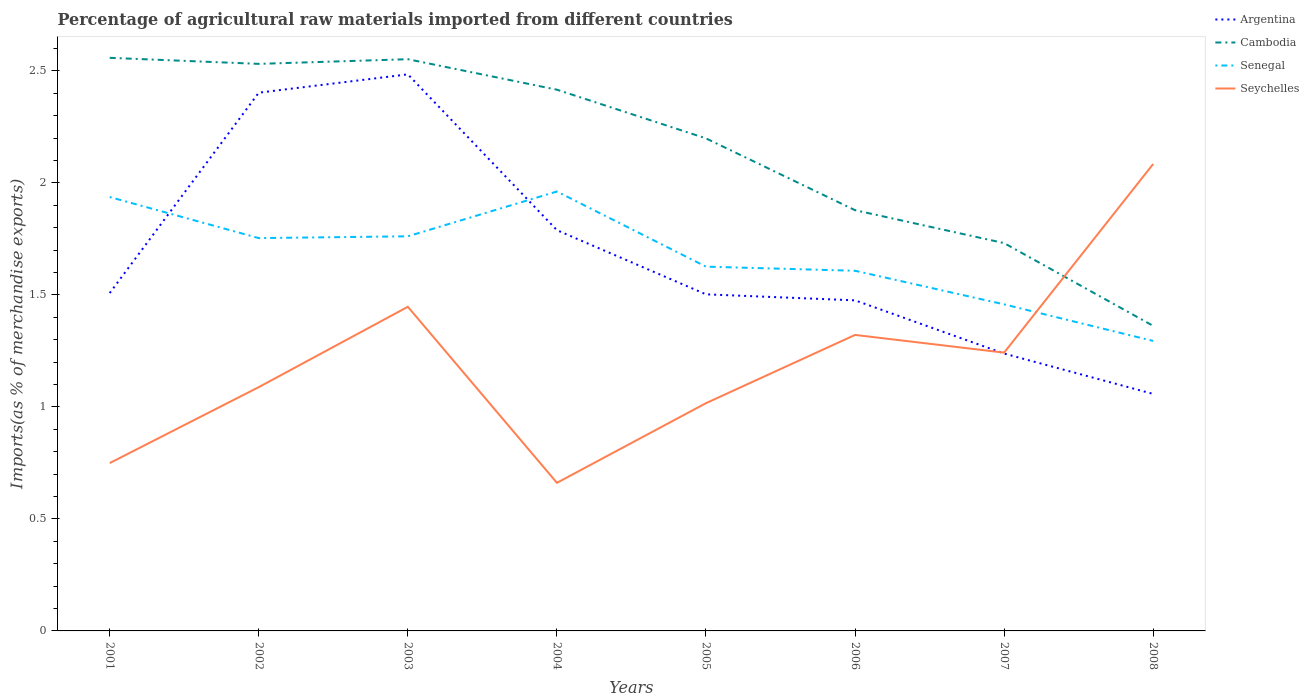How many different coloured lines are there?
Give a very brief answer. 4. Does the line corresponding to Senegal intersect with the line corresponding to Argentina?
Give a very brief answer. Yes. Across all years, what is the maximum percentage of imports to different countries in Seychelles?
Your response must be concise. 0.66. In which year was the percentage of imports to different countries in Cambodia maximum?
Give a very brief answer. 2008. What is the total percentage of imports to different countries in Senegal in the graph?
Offer a terse response. 0.64. What is the difference between the highest and the second highest percentage of imports to different countries in Senegal?
Your answer should be compact. 0.67. What is the difference between the highest and the lowest percentage of imports to different countries in Cambodia?
Provide a succinct answer. 5. How many lines are there?
Keep it short and to the point. 4. How many years are there in the graph?
Your answer should be very brief. 8. Are the values on the major ticks of Y-axis written in scientific E-notation?
Ensure brevity in your answer.  No. Does the graph contain grids?
Make the answer very short. No. What is the title of the graph?
Give a very brief answer. Percentage of agricultural raw materials imported from different countries. Does "St. Lucia" appear as one of the legend labels in the graph?
Give a very brief answer. No. What is the label or title of the Y-axis?
Your answer should be compact. Imports(as % of merchandise exports). What is the Imports(as % of merchandise exports) in Argentina in 2001?
Make the answer very short. 1.51. What is the Imports(as % of merchandise exports) in Cambodia in 2001?
Your answer should be very brief. 2.56. What is the Imports(as % of merchandise exports) in Senegal in 2001?
Provide a succinct answer. 1.94. What is the Imports(as % of merchandise exports) of Seychelles in 2001?
Make the answer very short. 0.75. What is the Imports(as % of merchandise exports) of Argentina in 2002?
Ensure brevity in your answer.  2.4. What is the Imports(as % of merchandise exports) of Cambodia in 2002?
Offer a terse response. 2.53. What is the Imports(as % of merchandise exports) of Senegal in 2002?
Provide a short and direct response. 1.75. What is the Imports(as % of merchandise exports) of Seychelles in 2002?
Provide a short and direct response. 1.09. What is the Imports(as % of merchandise exports) in Argentina in 2003?
Offer a terse response. 2.48. What is the Imports(as % of merchandise exports) of Cambodia in 2003?
Your answer should be very brief. 2.55. What is the Imports(as % of merchandise exports) of Senegal in 2003?
Your answer should be compact. 1.76. What is the Imports(as % of merchandise exports) of Seychelles in 2003?
Ensure brevity in your answer.  1.45. What is the Imports(as % of merchandise exports) in Argentina in 2004?
Offer a terse response. 1.79. What is the Imports(as % of merchandise exports) of Cambodia in 2004?
Ensure brevity in your answer.  2.42. What is the Imports(as % of merchandise exports) of Senegal in 2004?
Provide a short and direct response. 1.96. What is the Imports(as % of merchandise exports) in Seychelles in 2004?
Your answer should be compact. 0.66. What is the Imports(as % of merchandise exports) in Argentina in 2005?
Provide a short and direct response. 1.5. What is the Imports(as % of merchandise exports) of Cambodia in 2005?
Keep it short and to the point. 2.2. What is the Imports(as % of merchandise exports) in Senegal in 2005?
Provide a succinct answer. 1.63. What is the Imports(as % of merchandise exports) in Seychelles in 2005?
Ensure brevity in your answer.  1.02. What is the Imports(as % of merchandise exports) in Argentina in 2006?
Offer a terse response. 1.48. What is the Imports(as % of merchandise exports) of Cambodia in 2006?
Give a very brief answer. 1.88. What is the Imports(as % of merchandise exports) in Senegal in 2006?
Provide a succinct answer. 1.61. What is the Imports(as % of merchandise exports) in Seychelles in 2006?
Provide a short and direct response. 1.32. What is the Imports(as % of merchandise exports) of Argentina in 2007?
Offer a terse response. 1.24. What is the Imports(as % of merchandise exports) of Cambodia in 2007?
Give a very brief answer. 1.73. What is the Imports(as % of merchandise exports) of Senegal in 2007?
Offer a terse response. 1.46. What is the Imports(as % of merchandise exports) in Seychelles in 2007?
Offer a terse response. 1.24. What is the Imports(as % of merchandise exports) of Argentina in 2008?
Ensure brevity in your answer.  1.06. What is the Imports(as % of merchandise exports) in Cambodia in 2008?
Your response must be concise. 1.36. What is the Imports(as % of merchandise exports) of Senegal in 2008?
Ensure brevity in your answer.  1.29. What is the Imports(as % of merchandise exports) in Seychelles in 2008?
Give a very brief answer. 2.08. Across all years, what is the maximum Imports(as % of merchandise exports) in Argentina?
Ensure brevity in your answer.  2.48. Across all years, what is the maximum Imports(as % of merchandise exports) of Cambodia?
Your response must be concise. 2.56. Across all years, what is the maximum Imports(as % of merchandise exports) of Senegal?
Give a very brief answer. 1.96. Across all years, what is the maximum Imports(as % of merchandise exports) in Seychelles?
Provide a succinct answer. 2.08. Across all years, what is the minimum Imports(as % of merchandise exports) of Argentina?
Provide a succinct answer. 1.06. Across all years, what is the minimum Imports(as % of merchandise exports) in Cambodia?
Give a very brief answer. 1.36. Across all years, what is the minimum Imports(as % of merchandise exports) in Senegal?
Your answer should be compact. 1.29. Across all years, what is the minimum Imports(as % of merchandise exports) in Seychelles?
Offer a very short reply. 0.66. What is the total Imports(as % of merchandise exports) of Argentina in the graph?
Give a very brief answer. 13.46. What is the total Imports(as % of merchandise exports) of Cambodia in the graph?
Keep it short and to the point. 17.23. What is the total Imports(as % of merchandise exports) of Senegal in the graph?
Keep it short and to the point. 13.4. What is the total Imports(as % of merchandise exports) in Seychelles in the graph?
Keep it short and to the point. 9.61. What is the difference between the Imports(as % of merchandise exports) in Argentina in 2001 and that in 2002?
Your response must be concise. -0.89. What is the difference between the Imports(as % of merchandise exports) in Cambodia in 2001 and that in 2002?
Your response must be concise. 0.03. What is the difference between the Imports(as % of merchandise exports) in Senegal in 2001 and that in 2002?
Offer a very short reply. 0.18. What is the difference between the Imports(as % of merchandise exports) in Seychelles in 2001 and that in 2002?
Your response must be concise. -0.34. What is the difference between the Imports(as % of merchandise exports) of Argentina in 2001 and that in 2003?
Give a very brief answer. -0.98. What is the difference between the Imports(as % of merchandise exports) in Cambodia in 2001 and that in 2003?
Your response must be concise. 0.01. What is the difference between the Imports(as % of merchandise exports) of Senegal in 2001 and that in 2003?
Your response must be concise. 0.18. What is the difference between the Imports(as % of merchandise exports) of Seychelles in 2001 and that in 2003?
Provide a short and direct response. -0.7. What is the difference between the Imports(as % of merchandise exports) in Argentina in 2001 and that in 2004?
Your response must be concise. -0.28. What is the difference between the Imports(as % of merchandise exports) of Cambodia in 2001 and that in 2004?
Offer a very short reply. 0.14. What is the difference between the Imports(as % of merchandise exports) in Senegal in 2001 and that in 2004?
Your response must be concise. -0.02. What is the difference between the Imports(as % of merchandise exports) of Seychelles in 2001 and that in 2004?
Your answer should be very brief. 0.09. What is the difference between the Imports(as % of merchandise exports) in Argentina in 2001 and that in 2005?
Provide a short and direct response. 0.01. What is the difference between the Imports(as % of merchandise exports) of Cambodia in 2001 and that in 2005?
Give a very brief answer. 0.36. What is the difference between the Imports(as % of merchandise exports) of Senegal in 2001 and that in 2005?
Offer a terse response. 0.31. What is the difference between the Imports(as % of merchandise exports) of Seychelles in 2001 and that in 2005?
Make the answer very short. -0.27. What is the difference between the Imports(as % of merchandise exports) in Argentina in 2001 and that in 2006?
Provide a short and direct response. 0.03. What is the difference between the Imports(as % of merchandise exports) in Cambodia in 2001 and that in 2006?
Offer a terse response. 0.68. What is the difference between the Imports(as % of merchandise exports) in Senegal in 2001 and that in 2006?
Your answer should be very brief. 0.33. What is the difference between the Imports(as % of merchandise exports) in Seychelles in 2001 and that in 2006?
Keep it short and to the point. -0.57. What is the difference between the Imports(as % of merchandise exports) in Argentina in 2001 and that in 2007?
Give a very brief answer. 0.27. What is the difference between the Imports(as % of merchandise exports) of Cambodia in 2001 and that in 2007?
Provide a short and direct response. 0.83. What is the difference between the Imports(as % of merchandise exports) in Senegal in 2001 and that in 2007?
Give a very brief answer. 0.48. What is the difference between the Imports(as % of merchandise exports) in Seychelles in 2001 and that in 2007?
Your response must be concise. -0.49. What is the difference between the Imports(as % of merchandise exports) of Argentina in 2001 and that in 2008?
Ensure brevity in your answer.  0.45. What is the difference between the Imports(as % of merchandise exports) in Cambodia in 2001 and that in 2008?
Offer a terse response. 1.2. What is the difference between the Imports(as % of merchandise exports) in Senegal in 2001 and that in 2008?
Your answer should be compact. 0.64. What is the difference between the Imports(as % of merchandise exports) in Seychelles in 2001 and that in 2008?
Keep it short and to the point. -1.34. What is the difference between the Imports(as % of merchandise exports) of Argentina in 2002 and that in 2003?
Give a very brief answer. -0.08. What is the difference between the Imports(as % of merchandise exports) in Cambodia in 2002 and that in 2003?
Keep it short and to the point. -0.02. What is the difference between the Imports(as % of merchandise exports) in Senegal in 2002 and that in 2003?
Provide a succinct answer. -0.01. What is the difference between the Imports(as % of merchandise exports) of Seychelles in 2002 and that in 2003?
Make the answer very short. -0.36. What is the difference between the Imports(as % of merchandise exports) in Argentina in 2002 and that in 2004?
Your response must be concise. 0.61. What is the difference between the Imports(as % of merchandise exports) in Cambodia in 2002 and that in 2004?
Keep it short and to the point. 0.12. What is the difference between the Imports(as % of merchandise exports) in Senegal in 2002 and that in 2004?
Offer a terse response. -0.21. What is the difference between the Imports(as % of merchandise exports) in Seychelles in 2002 and that in 2004?
Make the answer very short. 0.43. What is the difference between the Imports(as % of merchandise exports) in Argentina in 2002 and that in 2005?
Provide a succinct answer. 0.9. What is the difference between the Imports(as % of merchandise exports) of Cambodia in 2002 and that in 2005?
Provide a short and direct response. 0.33. What is the difference between the Imports(as % of merchandise exports) in Senegal in 2002 and that in 2005?
Keep it short and to the point. 0.13. What is the difference between the Imports(as % of merchandise exports) in Seychelles in 2002 and that in 2005?
Ensure brevity in your answer.  0.07. What is the difference between the Imports(as % of merchandise exports) in Argentina in 2002 and that in 2006?
Give a very brief answer. 0.93. What is the difference between the Imports(as % of merchandise exports) in Cambodia in 2002 and that in 2006?
Provide a short and direct response. 0.65. What is the difference between the Imports(as % of merchandise exports) of Senegal in 2002 and that in 2006?
Give a very brief answer. 0.15. What is the difference between the Imports(as % of merchandise exports) in Seychelles in 2002 and that in 2006?
Provide a short and direct response. -0.23. What is the difference between the Imports(as % of merchandise exports) of Argentina in 2002 and that in 2007?
Provide a succinct answer. 1.16. What is the difference between the Imports(as % of merchandise exports) of Cambodia in 2002 and that in 2007?
Provide a succinct answer. 0.8. What is the difference between the Imports(as % of merchandise exports) of Senegal in 2002 and that in 2007?
Your response must be concise. 0.3. What is the difference between the Imports(as % of merchandise exports) of Seychelles in 2002 and that in 2007?
Provide a short and direct response. -0.15. What is the difference between the Imports(as % of merchandise exports) of Argentina in 2002 and that in 2008?
Provide a succinct answer. 1.34. What is the difference between the Imports(as % of merchandise exports) in Cambodia in 2002 and that in 2008?
Provide a short and direct response. 1.17. What is the difference between the Imports(as % of merchandise exports) of Senegal in 2002 and that in 2008?
Ensure brevity in your answer.  0.46. What is the difference between the Imports(as % of merchandise exports) of Seychelles in 2002 and that in 2008?
Your answer should be compact. -1. What is the difference between the Imports(as % of merchandise exports) of Argentina in 2003 and that in 2004?
Offer a terse response. 0.7. What is the difference between the Imports(as % of merchandise exports) in Cambodia in 2003 and that in 2004?
Offer a terse response. 0.14. What is the difference between the Imports(as % of merchandise exports) of Seychelles in 2003 and that in 2004?
Your answer should be compact. 0.79. What is the difference between the Imports(as % of merchandise exports) of Argentina in 2003 and that in 2005?
Your answer should be compact. 0.98. What is the difference between the Imports(as % of merchandise exports) in Cambodia in 2003 and that in 2005?
Your answer should be very brief. 0.35. What is the difference between the Imports(as % of merchandise exports) in Senegal in 2003 and that in 2005?
Your response must be concise. 0.14. What is the difference between the Imports(as % of merchandise exports) in Seychelles in 2003 and that in 2005?
Give a very brief answer. 0.43. What is the difference between the Imports(as % of merchandise exports) of Argentina in 2003 and that in 2006?
Provide a short and direct response. 1.01. What is the difference between the Imports(as % of merchandise exports) in Cambodia in 2003 and that in 2006?
Your response must be concise. 0.67. What is the difference between the Imports(as % of merchandise exports) of Senegal in 2003 and that in 2006?
Give a very brief answer. 0.15. What is the difference between the Imports(as % of merchandise exports) in Seychelles in 2003 and that in 2006?
Keep it short and to the point. 0.13. What is the difference between the Imports(as % of merchandise exports) in Argentina in 2003 and that in 2007?
Make the answer very short. 1.25. What is the difference between the Imports(as % of merchandise exports) in Cambodia in 2003 and that in 2007?
Your answer should be compact. 0.82. What is the difference between the Imports(as % of merchandise exports) in Senegal in 2003 and that in 2007?
Provide a succinct answer. 0.3. What is the difference between the Imports(as % of merchandise exports) in Seychelles in 2003 and that in 2007?
Ensure brevity in your answer.  0.2. What is the difference between the Imports(as % of merchandise exports) of Argentina in 2003 and that in 2008?
Your answer should be very brief. 1.43. What is the difference between the Imports(as % of merchandise exports) of Cambodia in 2003 and that in 2008?
Offer a very short reply. 1.19. What is the difference between the Imports(as % of merchandise exports) in Senegal in 2003 and that in 2008?
Offer a terse response. 0.47. What is the difference between the Imports(as % of merchandise exports) in Seychelles in 2003 and that in 2008?
Provide a succinct answer. -0.64. What is the difference between the Imports(as % of merchandise exports) of Argentina in 2004 and that in 2005?
Offer a very short reply. 0.29. What is the difference between the Imports(as % of merchandise exports) of Cambodia in 2004 and that in 2005?
Offer a very short reply. 0.22. What is the difference between the Imports(as % of merchandise exports) in Senegal in 2004 and that in 2005?
Provide a succinct answer. 0.34. What is the difference between the Imports(as % of merchandise exports) of Seychelles in 2004 and that in 2005?
Your answer should be very brief. -0.36. What is the difference between the Imports(as % of merchandise exports) in Argentina in 2004 and that in 2006?
Your response must be concise. 0.31. What is the difference between the Imports(as % of merchandise exports) of Cambodia in 2004 and that in 2006?
Provide a short and direct response. 0.54. What is the difference between the Imports(as % of merchandise exports) of Senegal in 2004 and that in 2006?
Give a very brief answer. 0.35. What is the difference between the Imports(as % of merchandise exports) of Seychelles in 2004 and that in 2006?
Offer a very short reply. -0.66. What is the difference between the Imports(as % of merchandise exports) of Argentina in 2004 and that in 2007?
Give a very brief answer. 0.55. What is the difference between the Imports(as % of merchandise exports) of Cambodia in 2004 and that in 2007?
Keep it short and to the point. 0.68. What is the difference between the Imports(as % of merchandise exports) in Senegal in 2004 and that in 2007?
Offer a terse response. 0.5. What is the difference between the Imports(as % of merchandise exports) in Seychelles in 2004 and that in 2007?
Keep it short and to the point. -0.58. What is the difference between the Imports(as % of merchandise exports) of Argentina in 2004 and that in 2008?
Provide a succinct answer. 0.73. What is the difference between the Imports(as % of merchandise exports) in Cambodia in 2004 and that in 2008?
Your answer should be compact. 1.05. What is the difference between the Imports(as % of merchandise exports) in Senegal in 2004 and that in 2008?
Give a very brief answer. 0.67. What is the difference between the Imports(as % of merchandise exports) in Seychelles in 2004 and that in 2008?
Offer a terse response. -1.42. What is the difference between the Imports(as % of merchandise exports) of Argentina in 2005 and that in 2006?
Your answer should be very brief. 0.03. What is the difference between the Imports(as % of merchandise exports) in Cambodia in 2005 and that in 2006?
Make the answer very short. 0.32. What is the difference between the Imports(as % of merchandise exports) of Senegal in 2005 and that in 2006?
Keep it short and to the point. 0.02. What is the difference between the Imports(as % of merchandise exports) of Seychelles in 2005 and that in 2006?
Your response must be concise. -0.3. What is the difference between the Imports(as % of merchandise exports) of Argentina in 2005 and that in 2007?
Offer a very short reply. 0.26. What is the difference between the Imports(as % of merchandise exports) of Cambodia in 2005 and that in 2007?
Offer a very short reply. 0.47. What is the difference between the Imports(as % of merchandise exports) in Senegal in 2005 and that in 2007?
Your answer should be compact. 0.17. What is the difference between the Imports(as % of merchandise exports) of Seychelles in 2005 and that in 2007?
Give a very brief answer. -0.23. What is the difference between the Imports(as % of merchandise exports) of Argentina in 2005 and that in 2008?
Offer a very short reply. 0.44. What is the difference between the Imports(as % of merchandise exports) in Cambodia in 2005 and that in 2008?
Keep it short and to the point. 0.84. What is the difference between the Imports(as % of merchandise exports) of Senegal in 2005 and that in 2008?
Ensure brevity in your answer.  0.33. What is the difference between the Imports(as % of merchandise exports) of Seychelles in 2005 and that in 2008?
Give a very brief answer. -1.07. What is the difference between the Imports(as % of merchandise exports) of Argentina in 2006 and that in 2007?
Provide a succinct answer. 0.24. What is the difference between the Imports(as % of merchandise exports) in Cambodia in 2006 and that in 2007?
Provide a short and direct response. 0.15. What is the difference between the Imports(as % of merchandise exports) in Seychelles in 2006 and that in 2007?
Provide a succinct answer. 0.08. What is the difference between the Imports(as % of merchandise exports) in Argentina in 2006 and that in 2008?
Provide a short and direct response. 0.42. What is the difference between the Imports(as % of merchandise exports) in Cambodia in 2006 and that in 2008?
Provide a succinct answer. 0.52. What is the difference between the Imports(as % of merchandise exports) in Senegal in 2006 and that in 2008?
Provide a succinct answer. 0.31. What is the difference between the Imports(as % of merchandise exports) of Seychelles in 2006 and that in 2008?
Your answer should be compact. -0.76. What is the difference between the Imports(as % of merchandise exports) in Argentina in 2007 and that in 2008?
Give a very brief answer. 0.18. What is the difference between the Imports(as % of merchandise exports) in Cambodia in 2007 and that in 2008?
Your answer should be very brief. 0.37. What is the difference between the Imports(as % of merchandise exports) of Senegal in 2007 and that in 2008?
Give a very brief answer. 0.16. What is the difference between the Imports(as % of merchandise exports) in Seychelles in 2007 and that in 2008?
Offer a very short reply. -0.84. What is the difference between the Imports(as % of merchandise exports) of Argentina in 2001 and the Imports(as % of merchandise exports) of Cambodia in 2002?
Offer a very short reply. -1.02. What is the difference between the Imports(as % of merchandise exports) of Argentina in 2001 and the Imports(as % of merchandise exports) of Senegal in 2002?
Your answer should be very brief. -0.25. What is the difference between the Imports(as % of merchandise exports) in Argentina in 2001 and the Imports(as % of merchandise exports) in Seychelles in 2002?
Your response must be concise. 0.42. What is the difference between the Imports(as % of merchandise exports) in Cambodia in 2001 and the Imports(as % of merchandise exports) in Senegal in 2002?
Offer a terse response. 0.8. What is the difference between the Imports(as % of merchandise exports) of Cambodia in 2001 and the Imports(as % of merchandise exports) of Seychelles in 2002?
Provide a short and direct response. 1.47. What is the difference between the Imports(as % of merchandise exports) in Senegal in 2001 and the Imports(as % of merchandise exports) in Seychelles in 2002?
Your answer should be compact. 0.85. What is the difference between the Imports(as % of merchandise exports) of Argentina in 2001 and the Imports(as % of merchandise exports) of Cambodia in 2003?
Offer a terse response. -1.04. What is the difference between the Imports(as % of merchandise exports) in Argentina in 2001 and the Imports(as % of merchandise exports) in Senegal in 2003?
Offer a terse response. -0.25. What is the difference between the Imports(as % of merchandise exports) in Argentina in 2001 and the Imports(as % of merchandise exports) in Seychelles in 2003?
Offer a very short reply. 0.06. What is the difference between the Imports(as % of merchandise exports) of Cambodia in 2001 and the Imports(as % of merchandise exports) of Senegal in 2003?
Offer a terse response. 0.8. What is the difference between the Imports(as % of merchandise exports) in Cambodia in 2001 and the Imports(as % of merchandise exports) in Seychelles in 2003?
Ensure brevity in your answer.  1.11. What is the difference between the Imports(as % of merchandise exports) of Senegal in 2001 and the Imports(as % of merchandise exports) of Seychelles in 2003?
Your answer should be very brief. 0.49. What is the difference between the Imports(as % of merchandise exports) of Argentina in 2001 and the Imports(as % of merchandise exports) of Cambodia in 2004?
Ensure brevity in your answer.  -0.91. What is the difference between the Imports(as % of merchandise exports) in Argentina in 2001 and the Imports(as % of merchandise exports) in Senegal in 2004?
Offer a very short reply. -0.45. What is the difference between the Imports(as % of merchandise exports) of Argentina in 2001 and the Imports(as % of merchandise exports) of Seychelles in 2004?
Provide a succinct answer. 0.85. What is the difference between the Imports(as % of merchandise exports) in Cambodia in 2001 and the Imports(as % of merchandise exports) in Senegal in 2004?
Provide a succinct answer. 0.6. What is the difference between the Imports(as % of merchandise exports) of Cambodia in 2001 and the Imports(as % of merchandise exports) of Seychelles in 2004?
Your answer should be compact. 1.9. What is the difference between the Imports(as % of merchandise exports) in Senegal in 2001 and the Imports(as % of merchandise exports) in Seychelles in 2004?
Keep it short and to the point. 1.28. What is the difference between the Imports(as % of merchandise exports) of Argentina in 2001 and the Imports(as % of merchandise exports) of Cambodia in 2005?
Give a very brief answer. -0.69. What is the difference between the Imports(as % of merchandise exports) of Argentina in 2001 and the Imports(as % of merchandise exports) of Senegal in 2005?
Keep it short and to the point. -0.12. What is the difference between the Imports(as % of merchandise exports) of Argentina in 2001 and the Imports(as % of merchandise exports) of Seychelles in 2005?
Make the answer very short. 0.49. What is the difference between the Imports(as % of merchandise exports) of Cambodia in 2001 and the Imports(as % of merchandise exports) of Senegal in 2005?
Keep it short and to the point. 0.93. What is the difference between the Imports(as % of merchandise exports) in Cambodia in 2001 and the Imports(as % of merchandise exports) in Seychelles in 2005?
Make the answer very short. 1.54. What is the difference between the Imports(as % of merchandise exports) in Senegal in 2001 and the Imports(as % of merchandise exports) in Seychelles in 2005?
Your answer should be compact. 0.92. What is the difference between the Imports(as % of merchandise exports) in Argentina in 2001 and the Imports(as % of merchandise exports) in Cambodia in 2006?
Your answer should be very brief. -0.37. What is the difference between the Imports(as % of merchandise exports) in Argentina in 2001 and the Imports(as % of merchandise exports) in Senegal in 2006?
Offer a terse response. -0.1. What is the difference between the Imports(as % of merchandise exports) of Argentina in 2001 and the Imports(as % of merchandise exports) of Seychelles in 2006?
Offer a very short reply. 0.19. What is the difference between the Imports(as % of merchandise exports) of Cambodia in 2001 and the Imports(as % of merchandise exports) of Senegal in 2006?
Make the answer very short. 0.95. What is the difference between the Imports(as % of merchandise exports) in Cambodia in 2001 and the Imports(as % of merchandise exports) in Seychelles in 2006?
Your response must be concise. 1.24. What is the difference between the Imports(as % of merchandise exports) in Senegal in 2001 and the Imports(as % of merchandise exports) in Seychelles in 2006?
Your answer should be compact. 0.62. What is the difference between the Imports(as % of merchandise exports) in Argentina in 2001 and the Imports(as % of merchandise exports) in Cambodia in 2007?
Your response must be concise. -0.22. What is the difference between the Imports(as % of merchandise exports) of Argentina in 2001 and the Imports(as % of merchandise exports) of Senegal in 2007?
Offer a terse response. 0.05. What is the difference between the Imports(as % of merchandise exports) of Argentina in 2001 and the Imports(as % of merchandise exports) of Seychelles in 2007?
Keep it short and to the point. 0.27. What is the difference between the Imports(as % of merchandise exports) in Cambodia in 2001 and the Imports(as % of merchandise exports) in Senegal in 2007?
Make the answer very short. 1.1. What is the difference between the Imports(as % of merchandise exports) of Cambodia in 2001 and the Imports(as % of merchandise exports) of Seychelles in 2007?
Provide a succinct answer. 1.32. What is the difference between the Imports(as % of merchandise exports) in Senegal in 2001 and the Imports(as % of merchandise exports) in Seychelles in 2007?
Your answer should be compact. 0.69. What is the difference between the Imports(as % of merchandise exports) of Argentina in 2001 and the Imports(as % of merchandise exports) of Cambodia in 2008?
Provide a succinct answer. 0.15. What is the difference between the Imports(as % of merchandise exports) of Argentina in 2001 and the Imports(as % of merchandise exports) of Senegal in 2008?
Your answer should be compact. 0.21. What is the difference between the Imports(as % of merchandise exports) in Argentina in 2001 and the Imports(as % of merchandise exports) in Seychelles in 2008?
Provide a succinct answer. -0.58. What is the difference between the Imports(as % of merchandise exports) of Cambodia in 2001 and the Imports(as % of merchandise exports) of Senegal in 2008?
Offer a terse response. 1.26. What is the difference between the Imports(as % of merchandise exports) of Cambodia in 2001 and the Imports(as % of merchandise exports) of Seychelles in 2008?
Give a very brief answer. 0.47. What is the difference between the Imports(as % of merchandise exports) of Senegal in 2001 and the Imports(as % of merchandise exports) of Seychelles in 2008?
Your answer should be compact. -0.15. What is the difference between the Imports(as % of merchandise exports) of Argentina in 2002 and the Imports(as % of merchandise exports) of Cambodia in 2003?
Your answer should be very brief. -0.15. What is the difference between the Imports(as % of merchandise exports) of Argentina in 2002 and the Imports(as % of merchandise exports) of Senegal in 2003?
Your response must be concise. 0.64. What is the difference between the Imports(as % of merchandise exports) of Argentina in 2002 and the Imports(as % of merchandise exports) of Seychelles in 2003?
Give a very brief answer. 0.96. What is the difference between the Imports(as % of merchandise exports) in Cambodia in 2002 and the Imports(as % of merchandise exports) in Senegal in 2003?
Ensure brevity in your answer.  0.77. What is the difference between the Imports(as % of merchandise exports) in Cambodia in 2002 and the Imports(as % of merchandise exports) in Seychelles in 2003?
Your response must be concise. 1.08. What is the difference between the Imports(as % of merchandise exports) in Senegal in 2002 and the Imports(as % of merchandise exports) in Seychelles in 2003?
Your response must be concise. 0.31. What is the difference between the Imports(as % of merchandise exports) of Argentina in 2002 and the Imports(as % of merchandise exports) of Cambodia in 2004?
Ensure brevity in your answer.  -0.01. What is the difference between the Imports(as % of merchandise exports) in Argentina in 2002 and the Imports(as % of merchandise exports) in Senegal in 2004?
Offer a terse response. 0.44. What is the difference between the Imports(as % of merchandise exports) in Argentina in 2002 and the Imports(as % of merchandise exports) in Seychelles in 2004?
Provide a short and direct response. 1.74. What is the difference between the Imports(as % of merchandise exports) of Cambodia in 2002 and the Imports(as % of merchandise exports) of Senegal in 2004?
Make the answer very short. 0.57. What is the difference between the Imports(as % of merchandise exports) in Cambodia in 2002 and the Imports(as % of merchandise exports) in Seychelles in 2004?
Your answer should be very brief. 1.87. What is the difference between the Imports(as % of merchandise exports) in Senegal in 2002 and the Imports(as % of merchandise exports) in Seychelles in 2004?
Give a very brief answer. 1.09. What is the difference between the Imports(as % of merchandise exports) in Argentina in 2002 and the Imports(as % of merchandise exports) in Cambodia in 2005?
Make the answer very short. 0.2. What is the difference between the Imports(as % of merchandise exports) of Argentina in 2002 and the Imports(as % of merchandise exports) of Senegal in 2005?
Offer a terse response. 0.78. What is the difference between the Imports(as % of merchandise exports) of Argentina in 2002 and the Imports(as % of merchandise exports) of Seychelles in 2005?
Keep it short and to the point. 1.39. What is the difference between the Imports(as % of merchandise exports) of Cambodia in 2002 and the Imports(as % of merchandise exports) of Senegal in 2005?
Your answer should be compact. 0.91. What is the difference between the Imports(as % of merchandise exports) of Cambodia in 2002 and the Imports(as % of merchandise exports) of Seychelles in 2005?
Keep it short and to the point. 1.51. What is the difference between the Imports(as % of merchandise exports) in Senegal in 2002 and the Imports(as % of merchandise exports) in Seychelles in 2005?
Give a very brief answer. 0.74. What is the difference between the Imports(as % of merchandise exports) in Argentina in 2002 and the Imports(as % of merchandise exports) in Cambodia in 2006?
Offer a terse response. 0.52. What is the difference between the Imports(as % of merchandise exports) in Argentina in 2002 and the Imports(as % of merchandise exports) in Senegal in 2006?
Provide a short and direct response. 0.8. What is the difference between the Imports(as % of merchandise exports) of Argentina in 2002 and the Imports(as % of merchandise exports) of Seychelles in 2006?
Keep it short and to the point. 1.08. What is the difference between the Imports(as % of merchandise exports) in Cambodia in 2002 and the Imports(as % of merchandise exports) in Senegal in 2006?
Ensure brevity in your answer.  0.92. What is the difference between the Imports(as % of merchandise exports) in Cambodia in 2002 and the Imports(as % of merchandise exports) in Seychelles in 2006?
Your answer should be very brief. 1.21. What is the difference between the Imports(as % of merchandise exports) of Senegal in 2002 and the Imports(as % of merchandise exports) of Seychelles in 2006?
Your answer should be compact. 0.43. What is the difference between the Imports(as % of merchandise exports) in Argentina in 2002 and the Imports(as % of merchandise exports) in Cambodia in 2007?
Make the answer very short. 0.67. What is the difference between the Imports(as % of merchandise exports) of Argentina in 2002 and the Imports(as % of merchandise exports) of Senegal in 2007?
Keep it short and to the point. 0.95. What is the difference between the Imports(as % of merchandise exports) in Argentina in 2002 and the Imports(as % of merchandise exports) in Seychelles in 2007?
Keep it short and to the point. 1.16. What is the difference between the Imports(as % of merchandise exports) of Cambodia in 2002 and the Imports(as % of merchandise exports) of Senegal in 2007?
Offer a very short reply. 1.07. What is the difference between the Imports(as % of merchandise exports) of Cambodia in 2002 and the Imports(as % of merchandise exports) of Seychelles in 2007?
Your answer should be compact. 1.29. What is the difference between the Imports(as % of merchandise exports) in Senegal in 2002 and the Imports(as % of merchandise exports) in Seychelles in 2007?
Provide a short and direct response. 0.51. What is the difference between the Imports(as % of merchandise exports) in Argentina in 2002 and the Imports(as % of merchandise exports) in Cambodia in 2008?
Your response must be concise. 1.04. What is the difference between the Imports(as % of merchandise exports) of Argentina in 2002 and the Imports(as % of merchandise exports) of Senegal in 2008?
Ensure brevity in your answer.  1.11. What is the difference between the Imports(as % of merchandise exports) of Argentina in 2002 and the Imports(as % of merchandise exports) of Seychelles in 2008?
Make the answer very short. 0.32. What is the difference between the Imports(as % of merchandise exports) of Cambodia in 2002 and the Imports(as % of merchandise exports) of Senegal in 2008?
Offer a very short reply. 1.24. What is the difference between the Imports(as % of merchandise exports) of Cambodia in 2002 and the Imports(as % of merchandise exports) of Seychelles in 2008?
Keep it short and to the point. 0.45. What is the difference between the Imports(as % of merchandise exports) of Senegal in 2002 and the Imports(as % of merchandise exports) of Seychelles in 2008?
Provide a short and direct response. -0.33. What is the difference between the Imports(as % of merchandise exports) in Argentina in 2003 and the Imports(as % of merchandise exports) in Cambodia in 2004?
Give a very brief answer. 0.07. What is the difference between the Imports(as % of merchandise exports) of Argentina in 2003 and the Imports(as % of merchandise exports) of Senegal in 2004?
Ensure brevity in your answer.  0.52. What is the difference between the Imports(as % of merchandise exports) of Argentina in 2003 and the Imports(as % of merchandise exports) of Seychelles in 2004?
Keep it short and to the point. 1.82. What is the difference between the Imports(as % of merchandise exports) of Cambodia in 2003 and the Imports(as % of merchandise exports) of Senegal in 2004?
Keep it short and to the point. 0.59. What is the difference between the Imports(as % of merchandise exports) in Cambodia in 2003 and the Imports(as % of merchandise exports) in Seychelles in 2004?
Keep it short and to the point. 1.89. What is the difference between the Imports(as % of merchandise exports) of Senegal in 2003 and the Imports(as % of merchandise exports) of Seychelles in 2004?
Your response must be concise. 1.1. What is the difference between the Imports(as % of merchandise exports) in Argentina in 2003 and the Imports(as % of merchandise exports) in Cambodia in 2005?
Your response must be concise. 0.29. What is the difference between the Imports(as % of merchandise exports) of Argentina in 2003 and the Imports(as % of merchandise exports) of Senegal in 2005?
Your answer should be compact. 0.86. What is the difference between the Imports(as % of merchandise exports) in Argentina in 2003 and the Imports(as % of merchandise exports) in Seychelles in 2005?
Your answer should be compact. 1.47. What is the difference between the Imports(as % of merchandise exports) in Cambodia in 2003 and the Imports(as % of merchandise exports) in Senegal in 2005?
Give a very brief answer. 0.93. What is the difference between the Imports(as % of merchandise exports) in Cambodia in 2003 and the Imports(as % of merchandise exports) in Seychelles in 2005?
Your response must be concise. 1.54. What is the difference between the Imports(as % of merchandise exports) of Senegal in 2003 and the Imports(as % of merchandise exports) of Seychelles in 2005?
Give a very brief answer. 0.74. What is the difference between the Imports(as % of merchandise exports) of Argentina in 2003 and the Imports(as % of merchandise exports) of Cambodia in 2006?
Give a very brief answer. 0.61. What is the difference between the Imports(as % of merchandise exports) in Argentina in 2003 and the Imports(as % of merchandise exports) in Senegal in 2006?
Ensure brevity in your answer.  0.88. What is the difference between the Imports(as % of merchandise exports) in Argentina in 2003 and the Imports(as % of merchandise exports) in Seychelles in 2006?
Ensure brevity in your answer.  1.16. What is the difference between the Imports(as % of merchandise exports) in Cambodia in 2003 and the Imports(as % of merchandise exports) in Senegal in 2006?
Ensure brevity in your answer.  0.94. What is the difference between the Imports(as % of merchandise exports) in Cambodia in 2003 and the Imports(as % of merchandise exports) in Seychelles in 2006?
Offer a terse response. 1.23. What is the difference between the Imports(as % of merchandise exports) in Senegal in 2003 and the Imports(as % of merchandise exports) in Seychelles in 2006?
Offer a very short reply. 0.44. What is the difference between the Imports(as % of merchandise exports) in Argentina in 2003 and the Imports(as % of merchandise exports) in Cambodia in 2007?
Your answer should be very brief. 0.75. What is the difference between the Imports(as % of merchandise exports) in Argentina in 2003 and the Imports(as % of merchandise exports) in Senegal in 2007?
Provide a succinct answer. 1.03. What is the difference between the Imports(as % of merchandise exports) of Argentina in 2003 and the Imports(as % of merchandise exports) of Seychelles in 2007?
Provide a succinct answer. 1.24. What is the difference between the Imports(as % of merchandise exports) in Cambodia in 2003 and the Imports(as % of merchandise exports) in Senegal in 2007?
Offer a very short reply. 1.09. What is the difference between the Imports(as % of merchandise exports) of Cambodia in 2003 and the Imports(as % of merchandise exports) of Seychelles in 2007?
Ensure brevity in your answer.  1.31. What is the difference between the Imports(as % of merchandise exports) in Senegal in 2003 and the Imports(as % of merchandise exports) in Seychelles in 2007?
Provide a succinct answer. 0.52. What is the difference between the Imports(as % of merchandise exports) in Argentina in 2003 and the Imports(as % of merchandise exports) in Cambodia in 2008?
Provide a short and direct response. 1.12. What is the difference between the Imports(as % of merchandise exports) of Argentina in 2003 and the Imports(as % of merchandise exports) of Senegal in 2008?
Keep it short and to the point. 1.19. What is the difference between the Imports(as % of merchandise exports) of Argentina in 2003 and the Imports(as % of merchandise exports) of Seychelles in 2008?
Offer a terse response. 0.4. What is the difference between the Imports(as % of merchandise exports) in Cambodia in 2003 and the Imports(as % of merchandise exports) in Senegal in 2008?
Offer a very short reply. 1.26. What is the difference between the Imports(as % of merchandise exports) in Cambodia in 2003 and the Imports(as % of merchandise exports) in Seychelles in 2008?
Provide a short and direct response. 0.47. What is the difference between the Imports(as % of merchandise exports) of Senegal in 2003 and the Imports(as % of merchandise exports) of Seychelles in 2008?
Offer a terse response. -0.32. What is the difference between the Imports(as % of merchandise exports) of Argentina in 2004 and the Imports(as % of merchandise exports) of Cambodia in 2005?
Provide a succinct answer. -0.41. What is the difference between the Imports(as % of merchandise exports) in Argentina in 2004 and the Imports(as % of merchandise exports) in Senegal in 2005?
Give a very brief answer. 0.16. What is the difference between the Imports(as % of merchandise exports) of Argentina in 2004 and the Imports(as % of merchandise exports) of Seychelles in 2005?
Your answer should be very brief. 0.77. What is the difference between the Imports(as % of merchandise exports) of Cambodia in 2004 and the Imports(as % of merchandise exports) of Senegal in 2005?
Provide a short and direct response. 0.79. What is the difference between the Imports(as % of merchandise exports) in Cambodia in 2004 and the Imports(as % of merchandise exports) in Seychelles in 2005?
Your answer should be compact. 1.4. What is the difference between the Imports(as % of merchandise exports) in Senegal in 2004 and the Imports(as % of merchandise exports) in Seychelles in 2005?
Provide a short and direct response. 0.94. What is the difference between the Imports(as % of merchandise exports) in Argentina in 2004 and the Imports(as % of merchandise exports) in Cambodia in 2006?
Ensure brevity in your answer.  -0.09. What is the difference between the Imports(as % of merchandise exports) of Argentina in 2004 and the Imports(as % of merchandise exports) of Senegal in 2006?
Provide a succinct answer. 0.18. What is the difference between the Imports(as % of merchandise exports) of Argentina in 2004 and the Imports(as % of merchandise exports) of Seychelles in 2006?
Provide a succinct answer. 0.47. What is the difference between the Imports(as % of merchandise exports) in Cambodia in 2004 and the Imports(as % of merchandise exports) in Senegal in 2006?
Offer a very short reply. 0.81. What is the difference between the Imports(as % of merchandise exports) of Cambodia in 2004 and the Imports(as % of merchandise exports) of Seychelles in 2006?
Provide a succinct answer. 1.09. What is the difference between the Imports(as % of merchandise exports) of Senegal in 2004 and the Imports(as % of merchandise exports) of Seychelles in 2006?
Provide a succinct answer. 0.64. What is the difference between the Imports(as % of merchandise exports) in Argentina in 2004 and the Imports(as % of merchandise exports) in Cambodia in 2007?
Your answer should be very brief. 0.06. What is the difference between the Imports(as % of merchandise exports) in Argentina in 2004 and the Imports(as % of merchandise exports) in Senegal in 2007?
Give a very brief answer. 0.33. What is the difference between the Imports(as % of merchandise exports) of Argentina in 2004 and the Imports(as % of merchandise exports) of Seychelles in 2007?
Give a very brief answer. 0.55. What is the difference between the Imports(as % of merchandise exports) of Cambodia in 2004 and the Imports(as % of merchandise exports) of Senegal in 2007?
Your response must be concise. 0.96. What is the difference between the Imports(as % of merchandise exports) of Cambodia in 2004 and the Imports(as % of merchandise exports) of Seychelles in 2007?
Ensure brevity in your answer.  1.17. What is the difference between the Imports(as % of merchandise exports) in Senegal in 2004 and the Imports(as % of merchandise exports) in Seychelles in 2007?
Your answer should be very brief. 0.72. What is the difference between the Imports(as % of merchandise exports) in Argentina in 2004 and the Imports(as % of merchandise exports) in Cambodia in 2008?
Ensure brevity in your answer.  0.43. What is the difference between the Imports(as % of merchandise exports) in Argentina in 2004 and the Imports(as % of merchandise exports) in Senegal in 2008?
Ensure brevity in your answer.  0.49. What is the difference between the Imports(as % of merchandise exports) in Argentina in 2004 and the Imports(as % of merchandise exports) in Seychelles in 2008?
Your answer should be very brief. -0.3. What is the difference between the Imports(as % of merchandise exports) in Cambodia in 2004 and the Imports(as % of merchandise exports) in Senegal in 2008?
Offer a very short reply. 1.12. What is the difference between the Imports(as % of merchandise exports) in Cambodia in 2004 and the Imports(as % of merchandise exports) in Seychelles in 2008?
Your answer should be very brief. 0.33. What is the difference between the Imports(as % of merchandise exports) of Senegal in 2004 and the Imports(as % of merchandise exports) of Seychelles in 2008?
Provide a short and direct response. -0.12. What is the difference between the Imports(as % of merchandise exports) of Argentina in 2005 and the Imports(as % of merchandise exports) of Cambodia in 2006?
Your response must be concise. -0.38. What is the difference between the Imports(as % of merchandise exports) of Argentina in 2005 and the Imports(as % of merchandise exports) of Senegal in 2006?
Keep it short and to the point. -0.11. What is the difference between the Imports(as % of merchandise exports) in Argentina in 2005 and the Imports(as % of merchandise exports) in Seychelles in 2006?
Your answer should be compact. 0.18. What is the difference between the Imports(as % of merchandise exports) of Cambodia in 2005 and the Imports(as % of merchandise exports) of Senegal in 2006?
Your answer should be compact. 0.59. What is the difference between the Imports(as % of merchandise exports) in Cambodia in 2005 and the Imports(as % of merchandise exports) in Seychelles in 2006?
Provide a succinct answer. 0.88. What is the difference between the Imports(as % of merchandise exports) of Senegal in 2005 and the Imports(as % of merchandise exports) of Seychelles in 2006?
Ensure brevity in your answer.  0.3. What is the difference between the Imports(as % of merchandise exports) of Argentina in 2005 and the Imports(as % of merchandise exports) of Cambodia in 2007?
Your answer should be compact. -0.23. What is the difference between the Imports(as % of merchandise exports) in Argentina in 2005 and the Imports(as % of merchandise exports) in Senegal in 2007?
Give a very brief answer. 0.04. What is the difference between the Imports(as % of merchandise exports) in Argentina in 2005 and the Imports(as % of merchandise exports) in Seychelles in 2007?
Keep it short and to the point. 0.26. What is the difference between the Imports(as % of merchandise exports) of Cambodia in 2005 and the Imports(as % of merchandise exports) of Senegal in 2007?
Make the answer very short. 0.74. What is the difference between the Imports(as % of merchandise exports) in Cambodia in 2005 and the Imports(as % of merchandise exports) in Seychelles in 2007?
Your answer should be very brief. 0.96. What is the difference between the Imports(as % of merchandise exports) of Senegal in 2005 and the Imports(as % of merchandise exports) of Seychelles in 2007?
Your answer should be compact. 0.38. What is the difference between the Imports(as % of merchandise exports) of Argentina in 2005 and the Imports(as % of merchandise exports) of Cambodia in 2008?
Make the answer very short. 0.14. What is the difference between the Imports(as % of merchandise exports) in Argentina in 2005 and the Imports(as % of merchandise exports) in Senegal in 2008?
Give a very brief answer. 0.21. What is the difference between the Imports(as % of merchandise exports) in Argentina in 2005 and the Imports(as % of merchandise exports) in Seychelles in 2008?
Keep it short and to the point. -0.58. What is the difference between the Imports(as % of merchandise exports) in Cambodia in 2005 and the Imports(as % of merchandise exports) in Senegal in 2008?
Make the answer very short. 0.9. What is the difference between the Imports(as % of merchandise exports) of Cambodia in 2005 and the Imports(as % of merchandise exports) of Seychelles in 2008?
Give a very brief answer. 0.11. What is the difference between the Imports(as % of merchandise exports) of Senegal in 2005 and the Imports(as % of merchandise exports) of Seychelles in 2008?
Ensure brevity in your answer.  -0.46. What is the difference between the Imports(as % of merchandise exports) in Argentina in 2006 and the Imports(as % of merchandise exports) in Cambodia in 2007?
Your answer should be very brief. -0.26. What is the difference between the Imports(as % of merchandise exports) in Argentina in 2006 and the Imports(as % of merchandise exports) in Senegal in 2007?
Offer a very short reply. 0.02. What is the difference between the Imports(as % of merchandise exports) of Argentina in 2006 and the Imports(as % of merchandise exports) of Seychelles in 2007?
Offer a terse response. 0.23. What is the difference between the Imports(as % of merchandise exports) in Cambodia in 2006 and the Imports(as % of merchandise exports) in Senegal in 2007?
Give a very brief answer. 0.42. What is the difference between the Imports(as % of merchandise exports) of Cambodia in 2006 and the Imports(as % of merchandise exports) of Seychelles in 2007?
Your response must be concise. 0.64. What is the difference between the Imports(as % of merchandise exports) in Senegal in 2006 and the Imports(as % of merchandise exports) in Seychelles in 2007?
Your response must be concise. 0.37. What is the difference between the Imports(as % of merchandise exports) of Argentina in 2006 and the Imports(as % of merchandise exports) of Cambodia in 2008?
Make the answer very short. 0.11. What is the difference between the Imports(as % of merchandise exports) of Argentina in 2006 and the Imports(as % of merchandise exports) of Senegal in 2008?
Offer a very short reply. 0.18. What is the difference between the Imports(as % of merchandise exports) of Argentina in 2006 and the Imports(as % of merchandise exports) of Seychelles in 2008?
Your answer should be very brief. -0.61. What is the difference between the Imports(as % of merchandise exports) of Cambodia in 2006 and the Imports(as % of merchandise exports) of Senegal in 2008?
Give a very brief answer. 0.58. What is the difference between the Imports(as % of merchandise exports) in Cambodia in 2006 and the Imports(as % of merchandise exports) in Seychelles in 2008?
Offer a very short reply. -0.21. What is the difference between the Imports(as % of merchandise exports) in Senegal in 2006 and the Imports(as % of merchandise exports) in Seychelles in 2008?
Provide a short and direct response. -0.48. What is the difference between the Imports(as % of merchandise exports) of Argentina in 2007 and the Imports(as % of merchandise exports) of Cambodia in 2008?
Provide a succinct answer. -0.12. What is the difference between the Imports(as % of merchandise exports) in Argentina in 2007 and the Imports(as % of merchandise exports) in Senegal in 2008?
Make the answer very short. -0.06. What is the difference between the Imports(as % of merchandise exports) of Argentina in 2007 and the Imports(as % of merchandise exports) of Seychelles in 2008?
Provide a short and direct response. -0.85. What is the difference between the Imports(as % of merchandise exports) in Cambodia in 2007 and the Imports(as % of merchandise exports) in Senegal in 2008?
Keep it short and to the point. 0.44. What is the difference between the Imports(as % of merchandise exports) of Cambodia in 2007 and the Imports(as % of merchandise exports) of Seychelles in 2008?
Your response must be concise. -0.35. What is the difference between the Imports(as % of merchandise exports) of Senegal in 2007 and the Imports(as % of merchandise exports) of Seychelles in 2008?
Provide a short and direct response. -0.63. What is the average Imports(as % of merchandise exports) of Argentina per year?
Provide a succinct answer. 1.68. What is the average Imports(as % of merchandise exports) in Cambodia per year?
Your answer should be very brief. 2.15. What is the average Imports(as % of merchandise exports) in Senegal per year?
Your response must be concise. 1.68. What is the average Imports(as % of merchandise exports) of Seychelles per year?
Your answer should be compact. 1.2. In the year 2001, what is the difference between the Imports(as % of merchandise exports) in Argentina and Imports(as % of merchandise exports) in Cambodia?
Your response must be concise. -1.05. In the year 2001, what is the difference between the Imports(as % of merchandise exports) of Argentina and Imports(as % of merchandise exports) of Senegal?
Provide a short and direct response. -0.43. In the year 2001, what is the difference between the Imports(as % of merchandise exports) in Argentina and Imports(as % of merchandise exports) in Seychelles?
Offer a very short reply. 0.76. In the year 2001, what is the difference between the Imports(as % of merchandise exports) of Cambodia and Imports(as % of merchandise exports) of Senegal?
Ensure brevity in your answer.  0.62. In the year 2001, what is the difference between the Imports(as % of merchandise exports) of Cambodia and Imports(as % of merchandise exports) of Seychelles?
Offer a very short reply. 1.81. In the year 2001, what is the difference between the Imports(as % of merchandise exports) of Senegal and Imports(as % of merchandise exports) of Seychelles?
Your response must be concise. 1.19. In the year 2002, what is the difference between the Imports(as % of merchandise exports) in Argentina and Imports(as % of merchandise exports) in Cambodia?
Your answer should be very brief. -0.13. In the year 2002, what is the difference between the Imports(as % of merchandise exports) in Argentina and Imports(as % of merchandise exports) in Senegal?
Your answer should be very brief. 0.65. In the year 2002, what is the difference between the Imports(as % of merchandise exports) in Argentina and Imports(as % of merchandise exports) in Seychelles?
Your response must be concise. 1.31. In the year 2002, what is the difference between the Imports(as % of merchandise exports) of Cambodia and Imports(as % of merchandise exports) of Senegal?
Your answer should be compact. 0.78. In the year 2002, what is the difference between the Imports(as % of merchandise exports) in Cambodia and Imports(as % of merchandise exports) in Seychelles?
Make the answer very short. 1.44. In the year 2002, what is the difference between the Imports(as % of merchandise exports) of Senegal and Imports(as % of merchandise exports) of Seychelles?
Ensure brevity in your answer.  0.67. In the year 2003, what is the difference between the Imports(as % of merchandise exports) in Argentina and Imports(as % of merchandise exports) in Cambodia?
Offer a very short reply. -0.07. In the year 2003, what is the difference between the Imports(as % of merchandise exports) of Argentina and Imports(as % of merchandise exports) of Senegal?
Provide a succinct answer. 0.72. In the year 2003, what is the difference between the Imports(as % of merchandise exports) of Argentina and Imports(as % of merchandise exports) of Seychelles?
Provide a succinct answer. 1.04. In the year 2003, what is the difference between the Imports(as % of merchandise exports) in Cambodia and Imports(as % of merchandise exports) in Senegal?
Make the answer very short. 0.79. In the year 2003, what is the difference between the Imports(as % of merchandise exports) of Cambodia and Imports(as % of merchandise exports) of Seychelles?
Your answer should be very brief. 1.11. In the year 2003, what is the difference between the Imports(as % of merchandise exports) of Senegal and Imports(as % of merchandise exports) of Seychelles?
Provide a succinct answer. 0.31. In the year 2004, what is the difference between the Imports(as % of merchandise exports) in Argentina and Imports(as % of merchandise exports) in Cambodia?
Make the answer very short. -0.63. In the year 2004, what is the difference between the Imports(as % of merchandise exports) in Argentina and Imports(as % of merchandise exports) in Senegal?
Your answer should be very brief. -0.17. In the year 2004, what is the difference between the Imports(as % of merchandise exports) in Argentina and Imports(as % of merchandise exports) in Seychelles?
Keep it short and to the point. 1.13. In the year 2004, what is the difference between the Imports(as % of merchandise exports) of Cambodia and Imports(as % of merchandise exports) of Senegal?
Offer a terse response. 0.45. In the year 2004, what is the difference between the Imports(as % of merchandise exports) of Cambodia and Imports(as % of merchandise exports) of Seychelles?
Your response must be concise. 1.76. In the year 2004, what is the difference between the Imports(as % of merchandise exports) of Senegal and Imports(as % of merchandise exports) of Seychelles?
Offer a terse response. 1.3. In the year 2005, what is the difference between the Imports(as % of merchandise exports) in Argentina and Imports(as % of merchandise exports) in Cambodia?
Provide a short and direct response. -0.7. In the year 2005, what is the difference between the Imports(as % of merchandise exports) in Argentina and Imports(as % of merchandise exports) in Senegal?
Make the answer very short. -0.12. In the year 2005, what is the difference between the Imports(as % of merchandise exports) of Argentina and Imports(as % of merchandise exports) of Seychelles?
Your response must be concise. 0.49. In the year 2005, what is the difference between the Imports(as % of merchandise exports) in Cambodia and Imports(as % of merchandise exports) in Senegal?
Your answer should be very brief. 0.57. In the year 2005, what is the difference between the Imports(as % of merchandise exports) in Cambodia and Imports(as % of merchandise exports) in Seychelles?
Keep it short and to the point. 1.18. In the year 2005, what is the difference between the Imports(as % of merchandise exports) in Senegal and Imports(as % of merchandise exports) in Seychelles?
Make the answer very short. 0.61. In the year 2006, what is the difference between the Imports(as % of merchandise exports) of Argentina and Imports(as % of merchandise exports) of Cambodia?
Give a very brief answer. -0.4. In the year 2006, what is the difference between the Imports(as % of merchandise exports) of Argentina and Imports(as % of merchandise exports) of Senegal?
Ensure brevity in your answer.  -0.13. In the year 2006, what is the difference between the Imports(as % of merchandise exports) in Argentina and Imports(as % of merchandise exports) in Seychelles?
Offer a terse response. 0.15. In the year 2006, what is the difference between the Imports(as % of merchandise exports) of Cambodia and Imports(as % of merchandise exports) of Senegal?
Your response must be concise. 0.27. In the year 2006, what is the difference between the Imports(as % of merchandise exports) of Cambodia and Imports(as % of merchandise exports) of Seychelles?
Your response must be concise. 0.56. In the year 2006, what is the difference between the Imports(as % of merchandise exports) in Senegal and Imports(as % of merchandise exports) in Seychelles?
Your answer should be compact. 0.29. In the year 2007, what is the difference between the Imports(as % of merchandise exports) of Argentina and Imports(as % of merchandise exports) of Cambodia?
Make the answer very short. -0.49. In the year 2007, what is the difference between the Imports(as % of merchandise exports) of Argentina and Imports(as % of merchandise exports) of Senegal?
Offer a terse response. -0.22. In the year 2007, what is the difference between the Imports(as % of merchandise exports) of Argentina and Imports(as % of merchandise exports) of Seychelles?
Offer a very short reply. -0. In the year 2007, what is the difference between the Imports(as % of merchandise exports) in Cambodia and Imports(as % of merchandise exports) in Senegal?
Make the answer very short. 0.27. In the year 2007, what is the difference between the Imports(as % of merchandise exports) of Cambodia and Imports(as % of merchandise exports) of Seychelles?
Keep it short and to the point. 0.49. In the year 2007, what is the difference between the Imports(as % of merchandise exports) in Senegal and Imports(as % of merchandise exports) in Seychelles?
Offer a terse response. 0.22. In the year 2008, what is the difference between the Imports(as % of merchandise exports) of Argentina and Imports(as % of merchandise exports) of Cambodia?
Give a very brief answer. -0.3. In the year 2008, what is the difference between the Imports(as % of merchandise exports) of Argentina and Imports(as % of merchandise exports) of Senegal?
Ensure brevity in your answer.  -0.24. In the year 2008, what is the difference between the Imports(as % of merchandise exports) of Argentina and Imports(as % of merchandise exports) of Seychelles?
Provide a short and direct response. -1.03. In the year 2008, what is the difference between the Imports(as % of merchandise exports) in Cambodia and Imports(as % of merchandise exports) in Senegal?
Your response must be concise. 0.07. In the year 2008, what is the difference between the Imports(as % of merchandise exports) of Cambodia and Imports(as % of merchandise exports) of Seychelles?
Your answer should be very brief. -0.72. In the year 2008, what is the difference between the Imports(as % of merchandise exports) in Senegal and Imports(as % of merchandise exports) in Seychelles?
Provide a succinct answer. -0.79. What is the ratio of the Imports(as % of merchandise exports) of Argentina in 2001 to that in 2002?
Your response must be concise. 0.63. What is the ratio of the Imports(as % of merchandise exports) in Cambodia in 2001 to that in 2002?
Provide a succinct answer. 1.01. What is the ratio of the Imports(as % of merchandise exports) in Senegal in 2001 to that in 2002?
Make the answer very short. 1.1. What is the ratio of the Imports(as % of merchandise exports) in Seychelles in 2001 to that in 2002?
Make the answer very short. 0.69. What is the ratio of the Imports(as % of merchandise exports) of Argentina in 2001 to that in 2003?
Provide a short and direct response. 0.61. What is the ratio of the Imports(as % of merchandise exports) in Senegal in 2001 to that in 2003?
Offer a terse response. 1.1. What is the ratio of the Imports(as % of merchandise exports) of Seychelles in 2001 to that in 2003?
Your response must be concise. 0.52. What is the ratio of the Imports(as % of merchandise exports) in Argentina in 2001 to that in 2004?
Offer a terse response. 0.84. What is the ratio of the Imports(as % of merchandise exports) of Cambodia in 2001 to that in 2004?
Make the answer very short. 1.06. What is the ratio of the Imports(as % of merchandise exports) of Senegal in 2001 to that in 2004?
Keep it short and to the point. 0.99. What is the ratio of the Imports(as % of merchandise exports) of Seychelles in 2001 to that in 2004?
Provide a short and direct response. 1.13. What is the ratio of the Imports(as % of merchandise exports) of Argentina in 2001 to that in 2005?
Make the answer very short. 1. What is the ratio of the Imports(as % of merchandise exports) of Cambodia in 2001 to that in 2005?
Make the answer very short. 1.16. What is the ratio of the Imports(as % of merchandise exports) of Senegal in 2001 to that in 2005?
Make the answer very short. 1.19. What is the ratio of the Imports(as % of merchandise exports) of Seychelles in 2001 to that in 2005?
Offer a terse response. 0.74. What is the ratio of the Imports(as % of merchandise exports) in Argentina in 2001 to that in 2006?
Ensure brevity in your answer.  1.02. What is the ratio of the Imports(as % of merchandise exports) of Cambodia in 2001 to that in 2006?
Your response must be concise. 1.36. What is the ratio of the Imports(as % of merchandise exports) of Senegal in 2001 to that in 2006?
Offer a very short reply. 1.2. What is the ratio of the Imports(as % of merchandise exports) of Seychelles in 2001 to that in 2006?
Provide a succinct answer. 0.57. What is the ratio of the Imports(as % of merchandise exports) of Argentina in 2001 to that in 2007?
Give a very brief answer. 1.22. What is the ratio of the Imports(as % of merchandise exports) of Cambodia in 2001 to that in 2007?
Make the answer very short. 1.48. What is the ratio of the Imports(as % of merchandise exports) in Senegal in 2001 to that in 2007?
Offer a very short reply. 1.33. What is the ratio of the Imports(as % of merchandise exports) of Seychelles in 2001 to that in 2007?
Provide a succinct answer. 0.6. What is the ratio of the Imports(as % of merchandise exports) of Argentina in 2001 to that in 2008?
Provide a succinct answer. 1.43. What is the ratio of the Imports(as % of merchandise exports) in Cambodia in 2001 to that in 2008?
Your answer should be compact. 1.88. What is the ratio of the Imports(as % of merchandise exports) of Senegal in 2001 to that in 2008?
Provide a short and direct response. 1.5. What is the ratio of the Imports(as % of merchandise exports) of Seychelles in 2001 to that in 2008?
Give a very brief answer. 0.36. What is the ratio of the Imports(as % of merchandise exports) of Argentina in 2002 to that in 2003?
Your answer should be very brief. 0.97. What is the ratio of the Imports(as % of merchandise exports) of Cambodia in 2002 to that in 2003?
Offer a very short reply. 0.99. What is the ratio of the Imports(as % of merchandise exports) in Seychelles in 2002 to that in 2003?
Offer a very short reply. 0.75. What is the ratio of the Imports(as % of merchandise exports) of Argentina in 2002 to that in 2004?
Your answer should be very brief. 1.34. What is the ratio of the Imports(as % of merchandise exports) in Cambodia in 2002 to that in 2004?
Offer a very short reply. 1.05. What is the ratio of the Imports(as % of merchandise exports) of Senegal in 2002 to that in 2004?
Ensure brevity in your answer.  0.89. What is the ratio of the Imports(as % of merchandise exports) in Seychelles in 2002 to that in 2004?
Offer a terse response. 1.65. What is the ratio of the Imports(as % of merchandise exports) in Argentina in 2002 to that in 2005?
Keep it short and to the point. 1.6. What is the ratio of the Imports(as % of merchandise exports) of Cambodia in 2002 to that in 2005?
Your response must be concise. 1.15. What is the ratio of the Imports(as % of merchandise exports) in Senegal in 2002 to that in 2005?
Your answer should be compact. 1.08. What is the ratio of the Imports(as % of merchandise exports) in Seychelles in 2002 to that in 2005?
Your answer should be compact. 1.07. What is the ratio of the Imports(as % of merchandise exports) in Argentina in 2002 to that in 2006?
Offer a terse response. 1.63. What is the ratio of the Imports(as % of merchandise exports) of Cambodia in 2002 to that in 2006?
Provide a short and direct response. 1.35. What is the ratio of the Imports(as % of merchandise exports) of Senegal in 2002 to that in 2006?
Make the answer very short. 1.09. What is the ratio of the Imports(as % of merchandise exports) in Seychelles in 2002 to that in 2006?
Provide a short and direct response. 0.82. What is the ratio of the Imports(as % of merchandise exports) in Argentina in 2002 to that in 2007?
Ensure brevity in your answer.  1.94. What is the ratio of the Imports(as % of merchandise exports) of Cambodia in 2002 to that in 2007?
Your answer should be compact. 1.46. What is the ratio of the Imports(as % of merchandise exports) of Senegal in 2002 to that in 2007?
Ensure brevity in your answer.  1.2. What is the ratio of the Imports(as % of merchandise exports) of Seychelles in 2002 to that in 2007?
Your answer should be compact. 0.88. What is the ratio of the Imports(as % of merchandise exports) of Argentina in 2002 to that in 2008?
Make the answer very short. 2.27. What is the ratio of the Imports(as % of merchandise exports) in Cambodia in 2002 to that in 2008?
Provide a short and direct response. 1.86. What is the ratio of the Imports(as % of merchandise exports) in Senegal in 2002 to that in 2008?
Provide a short and direct response. 1.35. What is the ratio of the Imports(as % of merchandise exports) in Seychelles in 2002 to that in 2008?
Your answer should be very brief. 0.52. What is the ratio of the Imports(as % of merchandise exports) in Argentina in 2003 to that in 2004?
Your response must be concise. 1.39. What is the ratio of the Imports(as % of merchandise exports) in Cambodia in 2003 to that in 2004?
Keep it short and to the point. 1.06. What is the ratio of the Imports(as % of merchandise exports) in Senegal in 2003 to that in 2004?
Give a very brief answer. 0.9. What is the ratio of the Imports(as % of merchandise exports) in Seychelles in 2003 to that in 2004?
Ensure brevity in your answer.  2.19. What is the ratio of the Imports(as % of merchandise exports) of Argentina in 2003 to that in 2005?
Your answer should be compact. 1.65. What is the ratio of the Imports(as % of merchandise exports) in Cambodia in 2003 to that in 2005?
Keep it short and to the point. 1.16. What is the ratio of the Imports(as % of merchandise exports) of Seychelles in 2003 to that in 2005?
Provide a short and direct response. 1.42. What is the ratio of the Imports(as % of merchandise exports) of Argentina in 2003 to that in 2006?
Offer a very short reply. 1.68. What is the ratio of the Imports(as % of merchandise exports) in Cambodia in 2003 to that in 2006?
Offer a very short reply. 1.36. What is the ratio of the Imports(as % of merchandise exports) of Senegal in 2003 to that in 2006?
Offer a very short reply. 1.1. What is the ratio of the Imports(as % of merchandise exports) of Seychelles in 2003 to that in 2006?
Your response must be concise. 1.1. What is the ratio of the Imports(as % of merchandise exports) in Argentina in 2003 to that in 2007?
Offer a very short reply. 2.01. What is the ratio of the Imports(as % of merchandise exports) in Cambodia in 2003 to that in 2007?
Ensure brevity in your answer.  1.47. What is the ratio of the Imports(as % of merchandise exports) of Senegal in 2003 to that in 2007?
Provide a succinct answer. 1.21. What is the ratio of the Imports(as % of merchandise exports) of Seychelles in 2003 to that in 2007?
Offer a terse response. 1.16. What is the ratio of the Imports(as % of merchandise exports) in Argentina in 2003 to that in 2008?
Your response must be concise. 2.35. What is the ratio of the Imports(as % of merchandise exports) of Cambodia in 2003 to that in 2008?
Provide a short and direct response. 1.87. What is the ratio of the Imports(as % of merchandise exports) of Senegal in 2003 to that in 2008?
Keep it short and to the point. 1.36. What is the ratio of the Imports(as % of merchandise exports) in Seychelles in 2003 to that in 2008?
Your answer should be very brief. 0.69. What is the ratio of the Imports(as % of merchandise exports) of Argentina in 2004 to that in 2005?
Keep it short and to the point. 1.19. What is the ratio of the Imports(as % of merchandise exports) in Cambodia in 2004 to that in 2005?
Provide a succinct answer. 1.1. What is the ratio of the Imports(as % of merchandise exports) in Senegal in 2004 to that in 2005?
Provide a short and direct response. 1.21. What is the ratio of the Imports(as % of merchandise exports) of Seychelles in 2004 to that in 2005?
Make the answer very short. 0.65. What is the ratio of the Imports(as % of merchandise exports) of Argentina in 2004 to that in 2006?
Provide a succinct answer. 1.21. What is the ratio of the Imports(as % of merchandise exports) of Cambodia in 2004 to that in 2006?
Offer a terse response. 1.29. What is the ratio of the Imports(as % of merchandise exports) of Senegal in 2004 to that in 2006?
Provide a short and direct response. 1.22. What is the ratio of the Imports(as % of merchandise exports) of Seychelles in 2004 to that in 2006?
Give a very brief answer. 0.5. What is the ratio of the Imports(as % of merchandise exports) of Argentina in 2004 to that in 2007?
Offer a terse response. 1.44. What is the ratio of the Imports(as % of merchandise exports) of Cambodia in 2004 to that in 2007?
Your answer should be compact. 1.4. What is the ratio of the Imports(as % of merchandise exports) in Senegal in 2004 to that in 2007?
Provide a succinct answer. 1.35. What is the ratio of the Imports(as % of merchandise exports) of Seychelles in 2004 to that in 2007?
Provide a succinct answer. 0.53. What is the ratio of the Imports(as % of merchandise exports) in Argentina in 2004 to that in 2008?
Ensure brevity in your answer.  1.69. What is the ratio of the Imports(as % of merchandise exports) of Cambodia in 2004 to that in 2008?
Keep it short and to the point. 1.77. What is the ratio of the Imports(as % of merchandise exports) in Senegal in 2004 to that in 2008?
Your answer should be very brief. 1.52. What is the ratio of the Imports(as % of merchandise exports) of Seychelles in 2004 to that in 2008?
Offer a terse response. 0.32. What is the ratio of the Imports(as % of merchandise exports) in Argentina in 2005 to that in 2006?
Offer a very short reply. 1.02. What is the ratio of the Imports(as % of merchandise exports) of Cambodia in 2005 to that in 2006?
Make the answer very short. 1.17. What is the ratio of the Imports(as % of merchandise exports) in Senegal in 2005 to that in 2006?
Make the answer very short. 1.01. What is the ratio of the Imports(as % of merchandise exports) in Seychelles in 2005 to that in 2006?
Provide a short and direct response. 0.77. What is the ratio of the Imports(as % of merchandise exports) of Argentina in 2005 to that in 2007?
Provide a succinct answer. 1.21. What is the ratio of the Imports(as % of merchandise exports) in Cambodia in 2005 to that in 2007?
Your answer should be compact. 1.27. What is the ratio of the Imports(as % of merchandise exports) in Senegal in 2005 to that in 2007?
Your response must be concise. 1.12. What is the ratio of the Imports(as % of merchandise exports) of Seychelles in 2005 to that in 2007?
Provide a succinct answer. 0.82. What is the ratio of the Imports(as % of merchandise exports) of Argentina in 2005 to that in 2008?
Provide a short and direct response. 1.42. What is the ratio of the Imports(as % of merchandise exports) of Cambodia in 2005 to that in 2008?
Provide a succinct answer. 1.61. What is the ratio of the Imports(as % of merchandise exports) in Senegal in 2005 to that in 2008?
Keep it short and to the point. 1.26. What is the ratio of the Imports(as % of merchandise exports) in Seychelles in 2005 to that in 2008?
Provide a succinct answer. 0.49. What is the ratio of the Imports(as % of merchandise exports) of Argentina in 2006 to that in 2007?
Make the answer very short. 1.19. What is the ratio of the Imports(as % of merchandise exports) in Cambodia in 2006 to that in 2007?
Make the answer very short. 1.08. What is the ratio of the Imports(as % of merchandise exports) in Senegal in 2006 to that in 2007?
Provide a short and direct response. 1.1. What is the ratio of the Imports(as % of merchandise exports) in Seychelles in 2006 to that in 2007?
Your response must be concise. 1.06. What is the ratio of the Imports(as % of merchandise exports) of Argentina in 2006 to that in 2008?
Provide a short and direct response. 1.39. What is the ratio of the Imports(as % of merchandise exports) in Cambodia in 2006 to that in 2008?
Keep it short and to the point. 1.38. What is the ratio of the Imports(as % of merchandise exports) of Senegal in 2006 to that in 2008?
Provide a short and direct response. 1.24. What is the ratio of the Imports(as % of merchandise exports) of Seychelles in 2006 to that in 2008?
Keep it short and to the point. 0.63. What is the ratio of the Imports(as % of merchandise exports) in Argentina in 2007 to that in 2008?
Ensure brevity in your answer.  1.17. What is the ratio of the Imports(as % of merchandise exports) of Cambodia in 2007 to that in 2008?
Offer a very short reply. 1.27. What is the ratio of the Imports(as % of merchandise exports) of Senegal in 2007 to that in 2008?
Your response must be concise. 1.13. What is the ratio of the Imports(as % of merchandise exports) of Seychelles in 2007 to that in 2008?
Offer a terse response. 0.6. What is the difference between the highest and the second highest Imports(as % of merchandise exports) of Argentina?
Your answer should be very brief. 0.08. What is the difference between the highest and the second highest Imports(as % of merchandise exports) in Cambodia?
Your answer should be compact. 0.01. What is the difference between the highest and the second highest Imports(as % of merchandise exports) in Senegal?
Give a very brief answer. 0.02. What is the difference between the highest and the second highest Imports(as % of merchandise exports) in Seychelles?
Your answer should be compact. 0.64. What is the difference between the highest and the lowest Imports(as % of merchandise exports) in Argentina?
Keep it short and to the point. 1.43. What is the difference between the highest and the lowest Imports(as % of merchandise exports) in Cambodia?
Your answer should be very brief. 1.2. What is the difference between the highest and the lowest Imports(as % of merchandise exports) in Senegal?
Give a very brief answer. 0.67. What is the difference between the highest and the lowest Imports(as % of merchandise exports) in Seychelles?
Your answer should be compact. 1.42. 